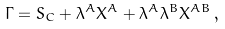<formula> <loc_0><loc_0><loc_500><loc_500>\Gamma = S _ { C } + \lambda ^ { A } X ^ { A } + \lambda ^ { A } \lambda ^ { B } X ^ { A B } \, ,</formula> 